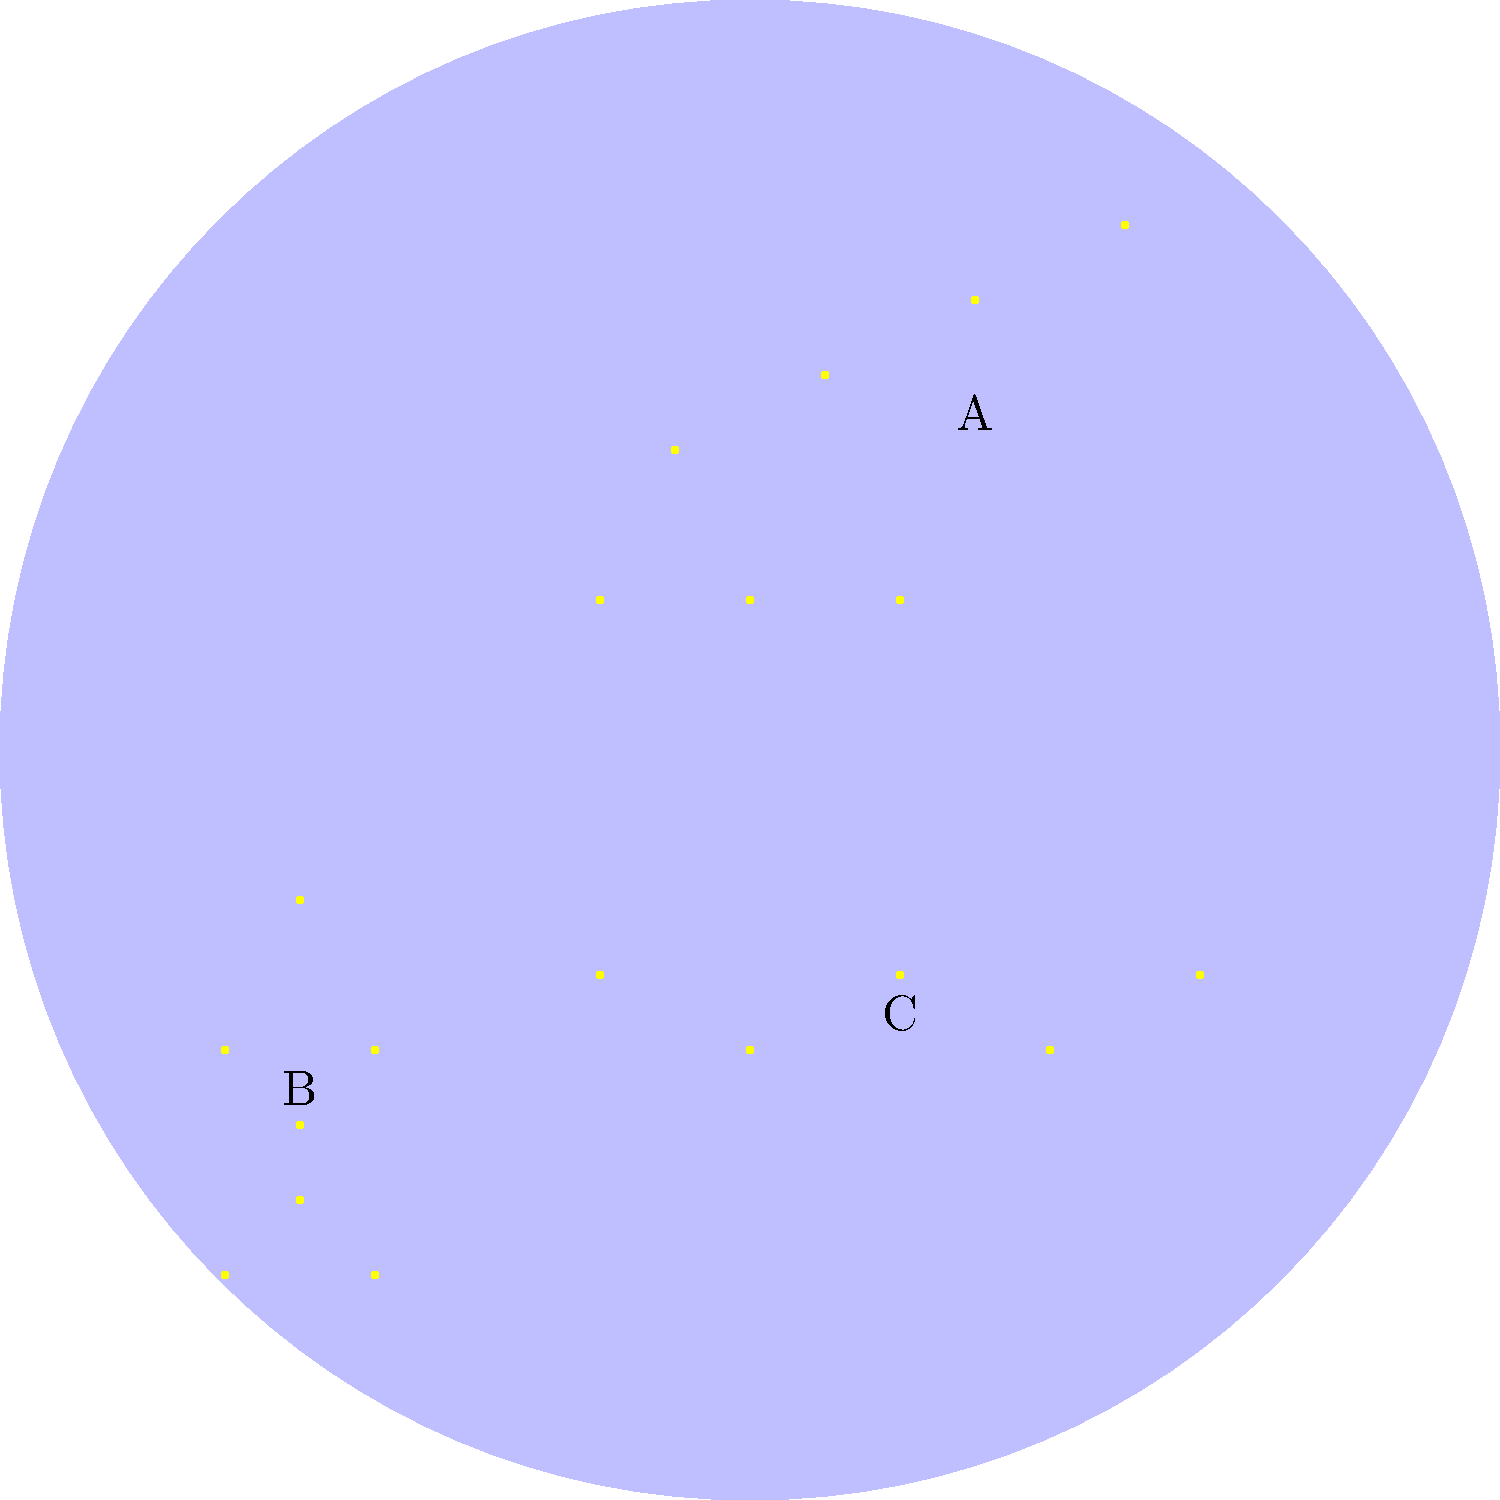Match the following constellations to their corresponding star patterns in the simplified sky chart above:

1. Big Dipper
2. Orion
3. Cassiopeia To match the constellations to their star patterns, let's examine each pattern in the sky chart:

1. Pattern A: This pattern shows seven stars arranged in a shape resembling a ladle or dipper. It has four stars forming a quadrilateral (the "bowl") and three stars extending from one corner (the "handle"). This distinctive shape is characteristic of the Big Dipper constellation.

2. Pattern B: This pattern displays seven prominent stars arranged in an hourglass shape. There are three stars in a row (Orion's Belt) with four bright stars surrounding it, forming the shoulders and feet of the constellation. This is the typical pattern of the Orion constellation.

3. Pattern C: This pattern shows five bright stars arranged in a distinctive W or M shape. This zigzag pattern is the hallmark of the Cassiopeia constellation, often described as resembling a queen's crown or chair.

By comparing these descriptions to the known shapes of the constellations, we can match them as follows:

- Big Dipper: Pattern A
- Orion: Pattern B
- Cassiopeia: Pattern C
Answer: 1-A, 2-B, 3-C 